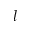<formula> <loc_0><loc_0><loc_500><loc_500>l</formula> 